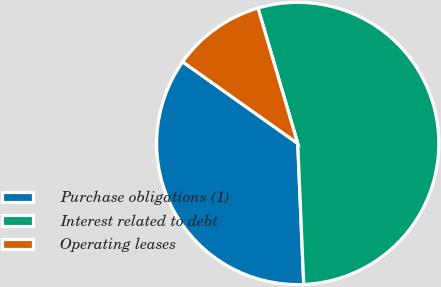Convert chart to OTSL. <chart><loc_0><loc_0><loc_500><loc_500><pie_chart><fcel>Purchase obligations (1)<fcel>Interest related to debt<fcel>Operating leases<nl><fcel>35.5%<fcel>53.87%<fcel>10.63%<nl></chart> 